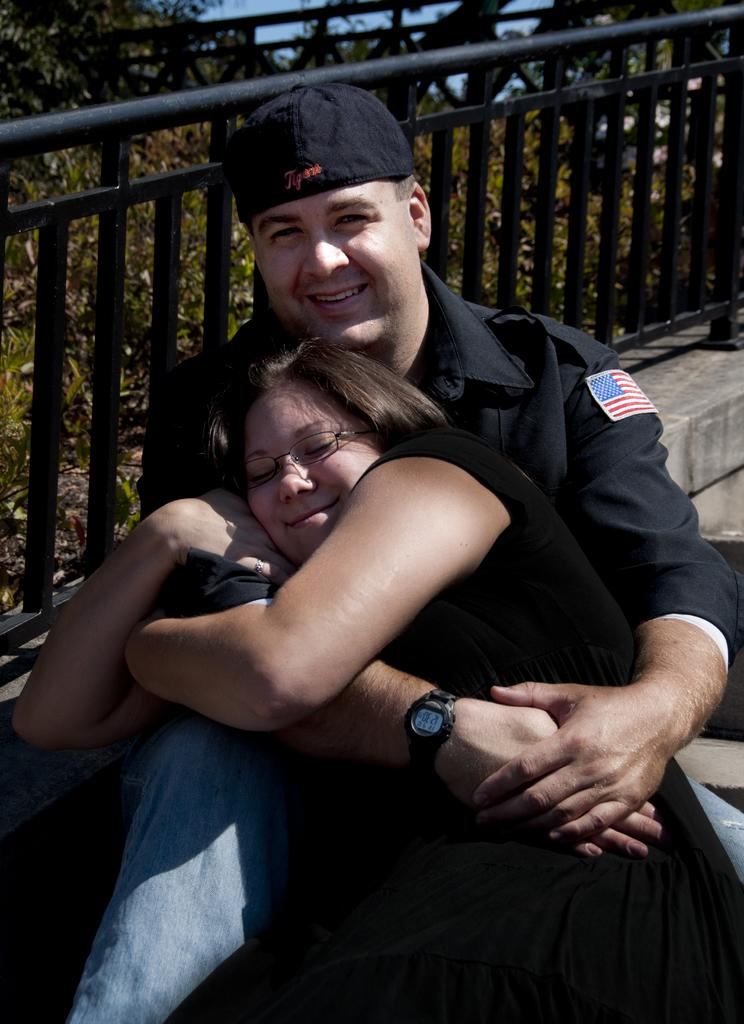Who can be seen in the foreground of the picture? There is a couple in the foreground of the picture. What is located in the center of the picture? There are plants and a railing in the center of the picture. What can be seen in the background of the picture? There is a tree and the sky visible in the background of the picture. Where is the straw store located in the image? There is no straw store present in the image. What type of alley can be seen in the image? There is no alley present in the image. 